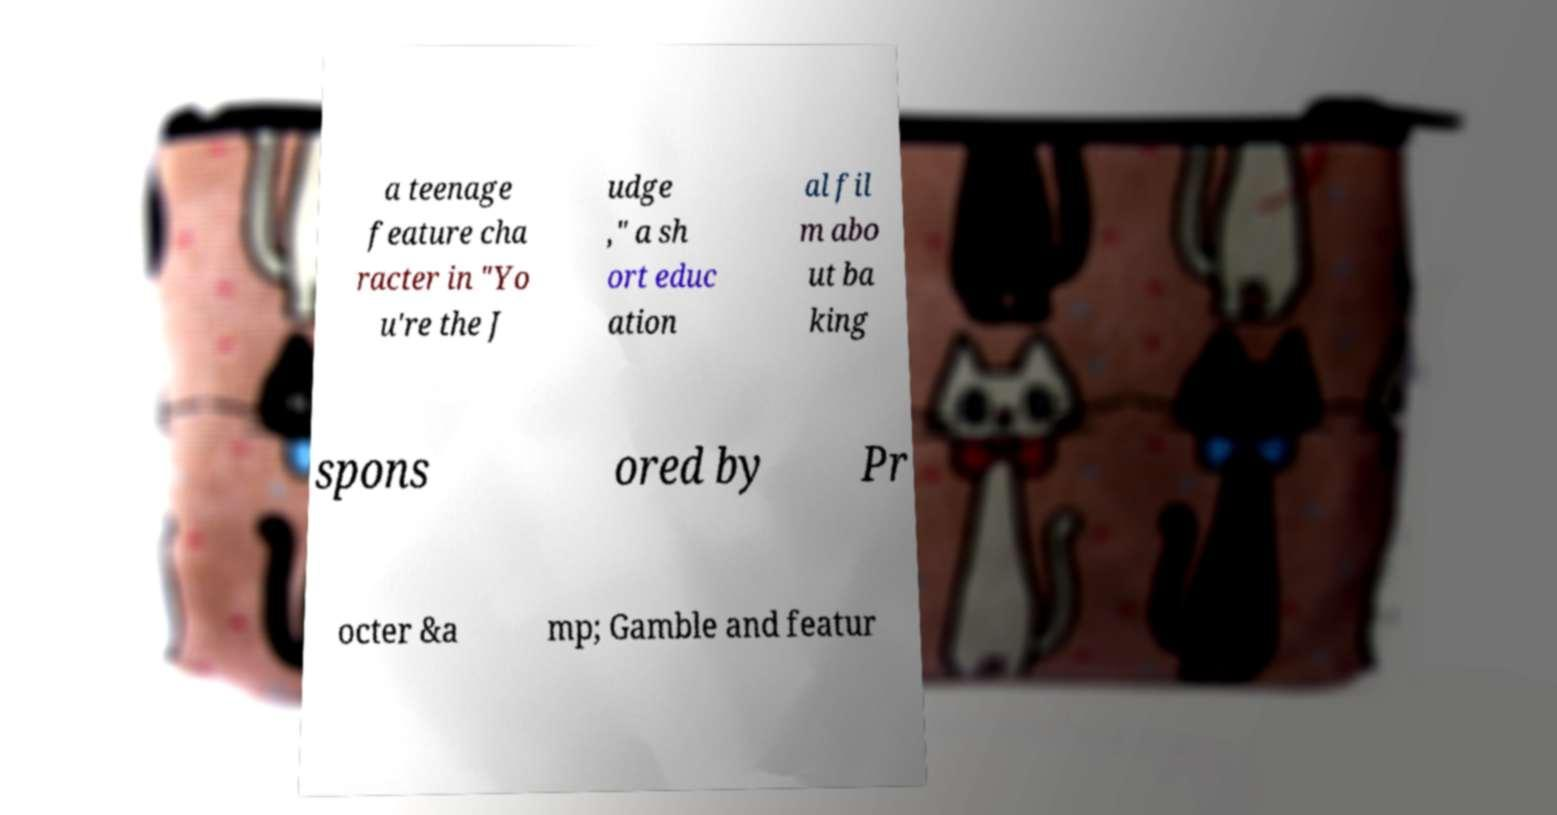I need the written content from this picture converted into text. Can you do that? a teenage feature cha racter in "Yo u're the J udge ," a sh ort educ ation al fil m abo ut ba king spons ored by Pr octer &a mp; Gamble and featur 